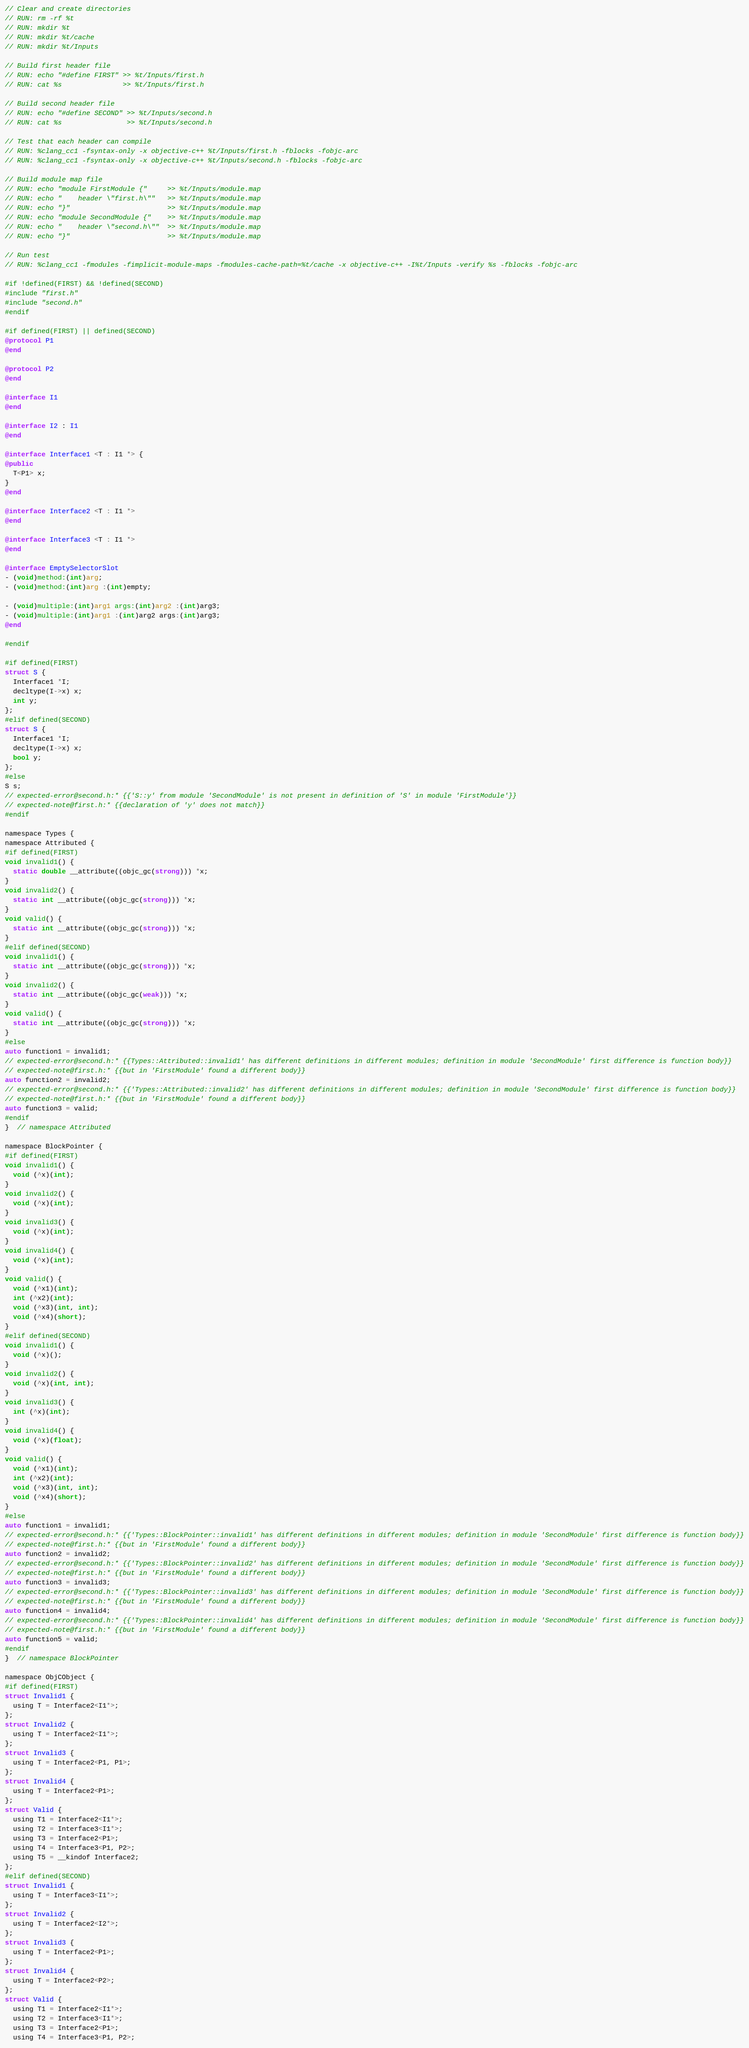Convert code to text. <code><loc_0><loc_0><loc_500><loc_500><_ObjectiveC_>// Clear and create directories
// RUN: rm -rf %t
// RUN: mkdir %t
// RUN: mkdir %t/cache
// RUN: mkdir %t/Inputs

// Build first header file
// RUN: echo "#define FIRST" >> %t/Inputs/first.h
// RUN: cat %s               >> %t/Inputs/first.h

// Build second header file
// RUN: echo "#define SECOND" >> %t/Inputs/second.h
// RUN: cat %s                >> %t/Inputs/second.h

// Test that each header can compile
// RUN: %clang_cc1 -fsyntax-only -x objective-c++ %t/Inputs/first.h -fblocks -fobjc-arc
// RUN: %clang_cc1 -fsyntax-only -x objective-c++ %t/Inputs/second.h -fblocks -fobjc-arc

// Build module map file
// RUN: echo "module FirstModule {"     >> %t/Inputs/module.map
// RUN: echo "    header \"first.h\""   >> %t/Inputs/module.map
// RUN: echo "}"                        >> %t/Inputs/module.map
// RUN: echo "module SecondModule {"    >> %t/Inputs/module.map
// RUN: echo "    header \"second.h\""  >> %t/Inputs/module.map
// RUN: echo "}"                        >> %t/Inputs/module.map

// Run test
// RUN: %clang_cc1 -fmodules -fimplicit-module-maps -fmodules-cache-path=%t/cache -x objective-c++ -I%t/Inputs -verify %s -fblocks -fobjc-arc

#if !defined(FIRST) && !defined(SECOND)
#include "first.h"
#include "second.h"
#endif

#if defined(FIRST) || defined(SECOND)
@protocol P1
@end

@protocol P2
@end

@interface I1
@end

@interface I2 : I1
@end

@interface Interface1 <T : I1 *> {
@public
  T<P1> x;
}
@end

@interface Interface2 <T : I1 *>
@end

@interface Interface3 <T : I1 *>
@end

@interface EmptySelectorSlot
- (void)method:(int)arg;
- (void)method:(int)arg :(int)empty;

- (void)multiple:(int)arg1 args:(int)arg2 :(int)arg3;
- (void)multiple:(int)arg1 :(int)arg2 args:(int)arg3;
@end

#endif

#if defined(FIRST)
struct S {
  Interface1 *I;
  decltype(I->x) x;
  int y;
};
#elif defined(SECOND)
struct S {
  Interface1 *I;
  decltype(I->x) x;
  bool y;
};
#else
S s;
// expected-error@second.h:* {{'S::y' from module 'SecondModule' is not present in definition of 'S' in module 'FirstModule'}}
// expected-note@first.h:* {{declaration of 'y' does not match}}
#endif

namespace Types {
namespace Attributed {
#if defined(FIRST)
void invalid1() {
  static double __attribute((objc_gc(strong))) *x;
}
void invalid2() {
  static int __attribute((objc_gc(strong))) *x;
}
void valid() {
  static int __attribute((objc_gc(strong))) *x;
}
#elif defined(SECOND)
void invalid1() {
  static int __attribute((objc_gc(strong))) *x;
}
void invalid2() {
  static int __attribute((objc_gc(weak))) *x;
}
void valid() {
  static int __attribute((objc_gc(strong))) *x;
}
#else
auto function1 = invalid1;
// expected-error@second.h:* {{Types::Attributed::invalid1' has different definitions in different modules; definition in module 'SecondModule' first difference is function body}}
// expected-note@first.h:* {{but in 'FirstModule' found a different body}}
auto function2 = invalid2;
// expected-error@second.h:* {{'Types::Attributed::invalid2' has different definitions in different modules; definition in module 'SecondModule' first difference is function body}}
// expected-note@first.h:* {{but in 'FirstModule' found a different body}}
auto function3 = valid;
#endif
}  // namespace Attributed

namespace BlockPointer {
#if defined(FIRST)
void invalid1() {
  void (^x)(int);
}
void invalid2() {
  void (^x)(int);
}
void invalid3() {
  void (^x)(int);
}
void invalid4() {
  void (^x)(int);
}
void valid() {
  void (^x1)(int);
  int (^x2)(int);
  void (^x3)(int, int);
  void (^x4)(short);
}
#elif defined(SECOND)
void invalid1() {
  void (^x)();
}
void invalid2() {
  void (^x)(int, int);
}
void invalid3() {
  int (^x)(int);
}
void invalid4() {
  void (^x)(float);
}
void valid() {
  void (^x1)(int);
  int (^x2)(int);
  void (^x3)(int, int);
  void (^x4)(short);
}
#else
auto function1 = invalid1;
// expected-error@second.h:* {{'Types::BlockPointer::invalid1' has different definitions in different modules; definition in module 'SecondModule' first difference is function body}}
// expected-note@first.h:* {{but in 'FirstModule' found a different body}}
auto function2 = invalid2;
// expected-error@second.h:* {{'Types::BlockPointer::invalid2' has different definitions in different modules; definition in module 'SecondModule' first difference is function body}}
// expected-note@first.h:* {{but in 'FirstModule' found a different body}}
auto function3 = invalid3;
// expected-error@second.h:* {{'Types::BlockPointer::invalid3' has different definitions in different modules; definition in module 'SecondModule' first difference is function body}}
// expected-note@first.h:* {{but in 'FirstModule' found a different body}}
auto function4 = invalid4;
// expected-error@second.h:* {{'Types::BlockPointer::invalid4' has different definitions in different modules; definition in module 'SecondModule' first difference is function body}}
// expected-note@first.h:* {{but in 'FirstModule' found a different body}}
auto function5 = valid;
#endif
}  // namespace BlockPointer

namespace ObjCObject {
#if defined(FIRST)
struct Invalid1 {
  using T = Interface2<I1*>;
};
struct Invalid2 {
  using T = Interface2<I1*>;
};
struct Invalid3 {
  using T = Interface2<P1, P1>;
};
struct Invalid4 {
  using T = Interface2<P1>;
};
struct Valid {
  using T1 = Interface2<I1*>;
  using T2 = Interface3<I1*>;
  using T3 = Interface2<P1>;
  using T4 = Interface3<P1, P2>;
  using T5 = __kindof Interface2;
};
#elif defined(SECOND)
struct Invalid1 {
  using T = Interface3<I1*>;
};
struct Invalid2 {
  using T = Interface2<I2*>;
};
struct Invalid3 {
  using T = Interface2<P1>;
};
struct Invalid4 {
  using T = Interface2<P2>;
};
struct Valid {
  using T1 = Interface2<I1*>;
  using T2 = Interface3<I1*>;
  using T3 = Interface2<P1>;
  using T4 = Interface3<P1, P2>;</code> 